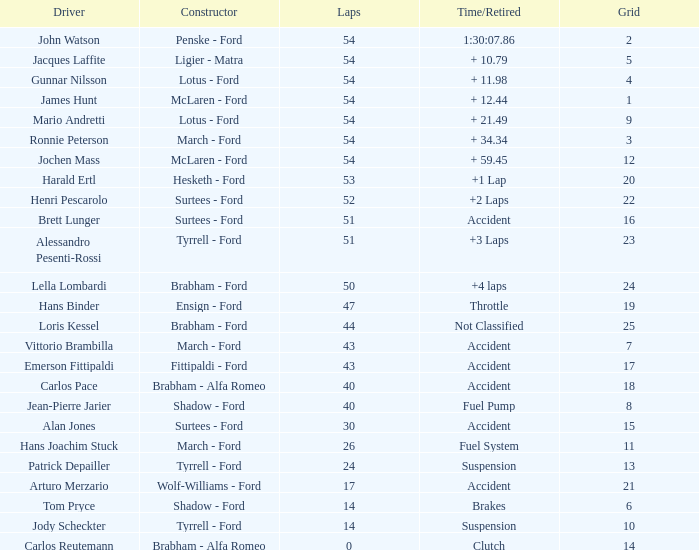When racing on a grid with more than 14 participants, how many laps did emerson fittipaldi finish, and what was the time of the accident or his retirement? 1.0. 